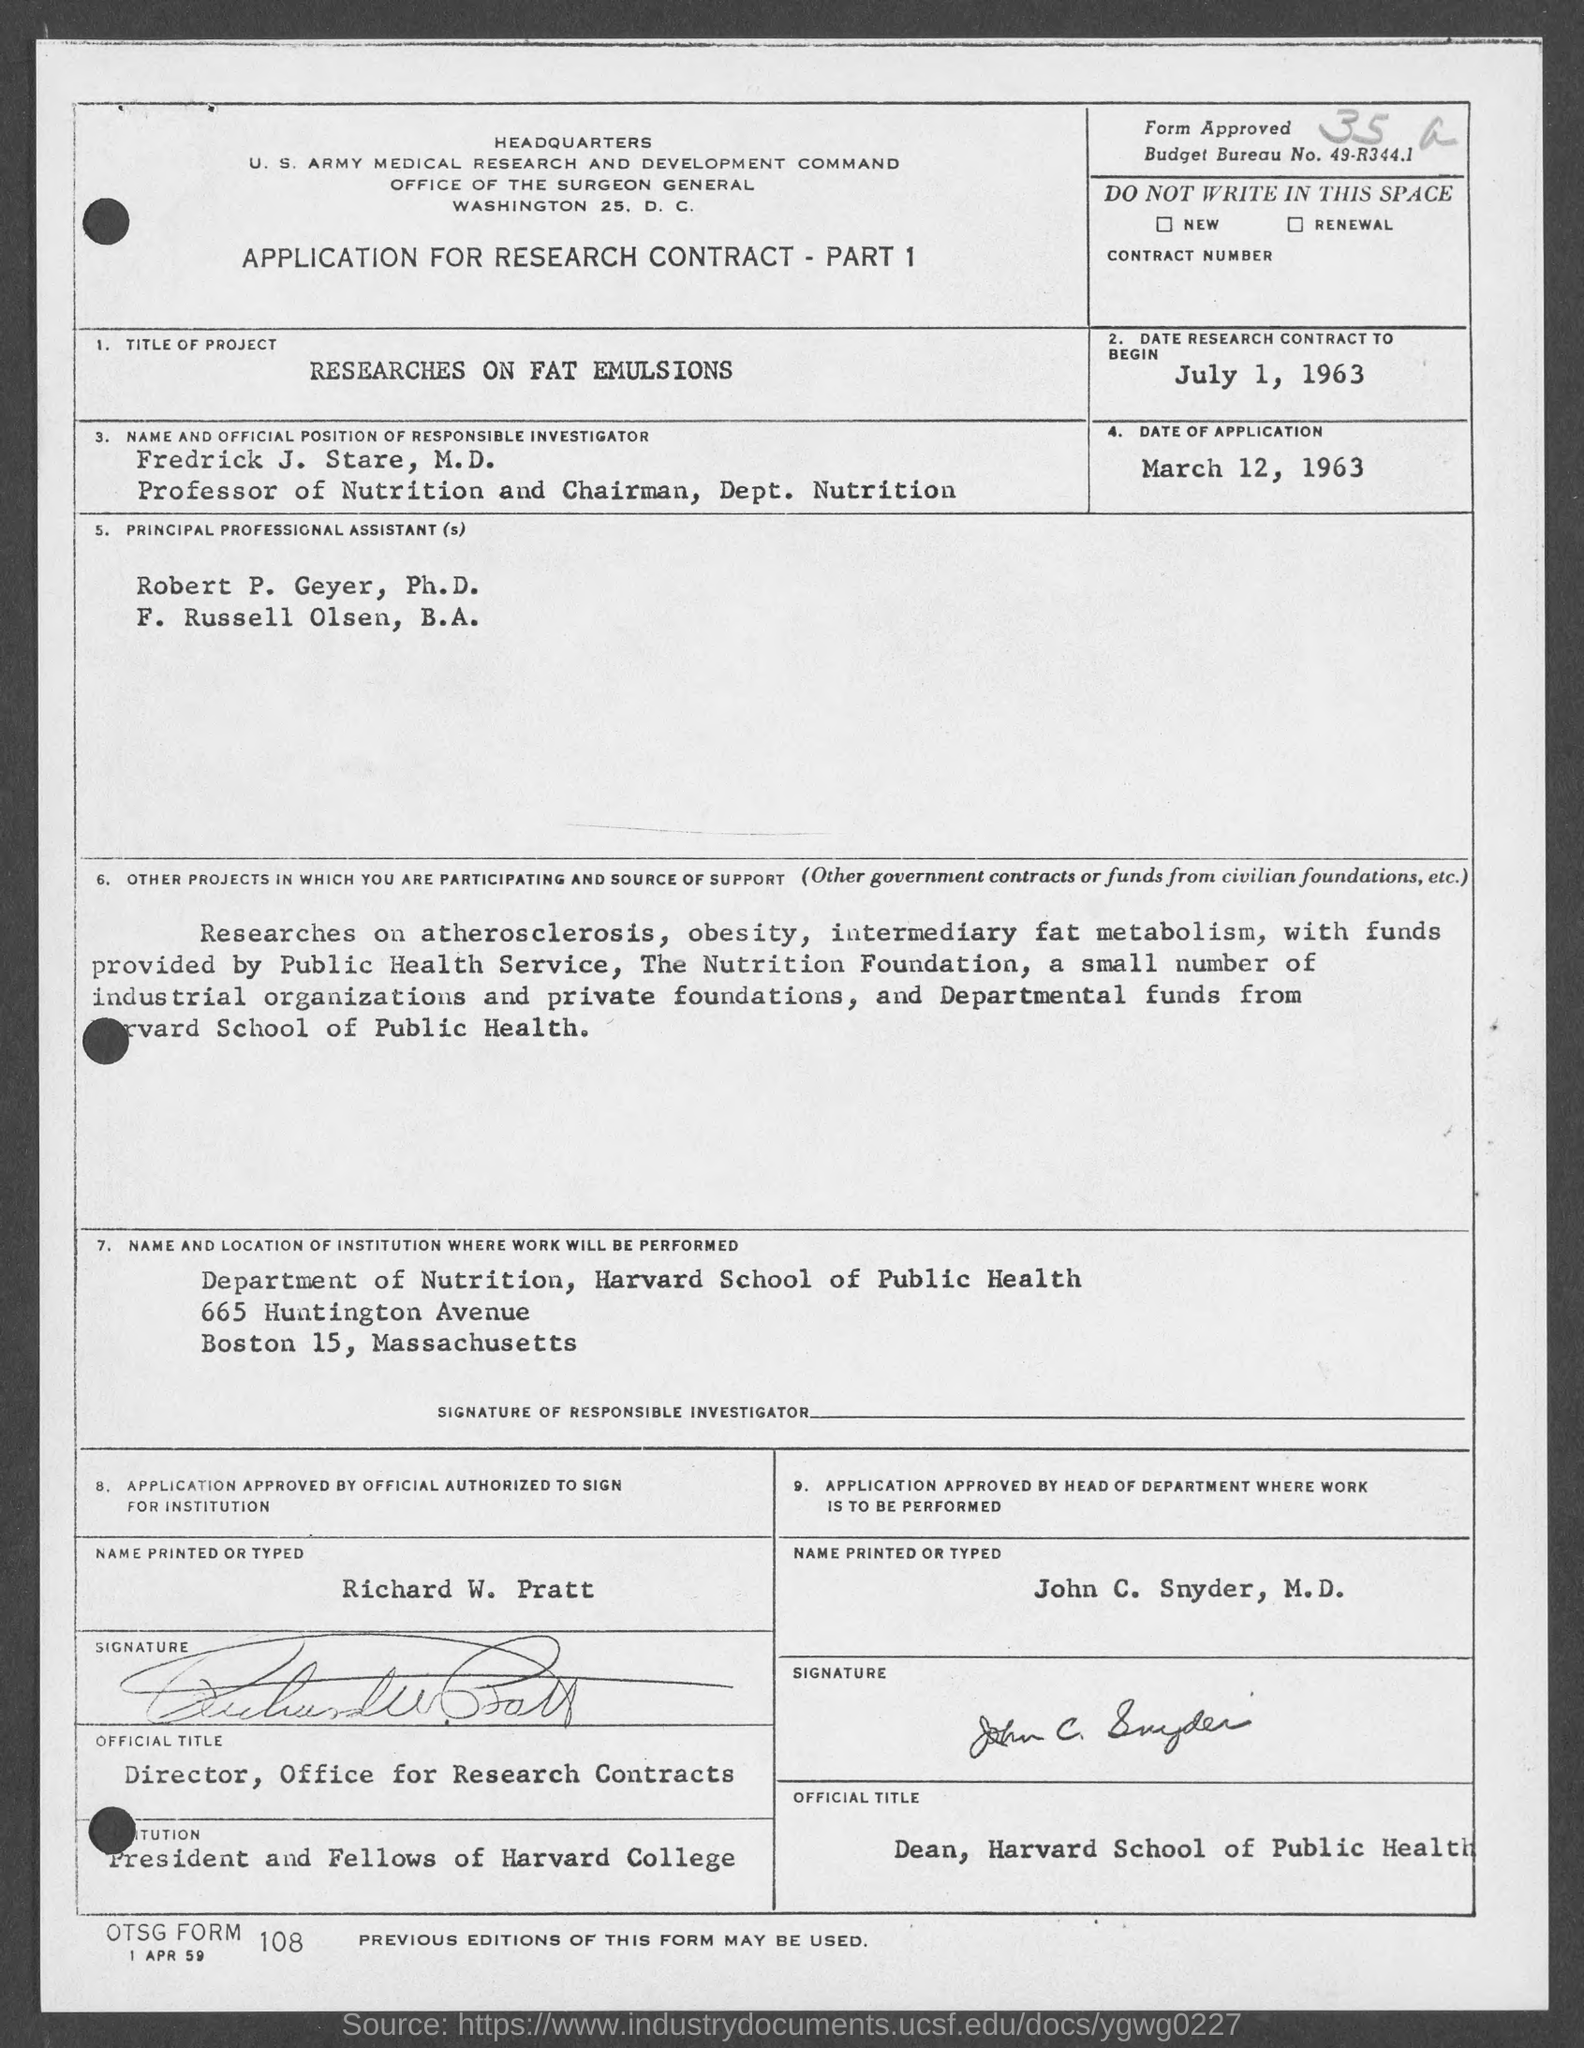Give some essential details in this illustration. The individual in charge of the Office for Research Contracts at the University is named Richard W. Pratt. Please provide the OTSG form number, which is 108... The date of application is March 12, 1963. On the bottom of the page, there is a date that reads "1 Apr 59. The date of the research contract's beginning is July 1, 1963. 